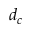<formula> <loc_0><loc_0><loc_500><loc_500>d _ { c }</formula> 